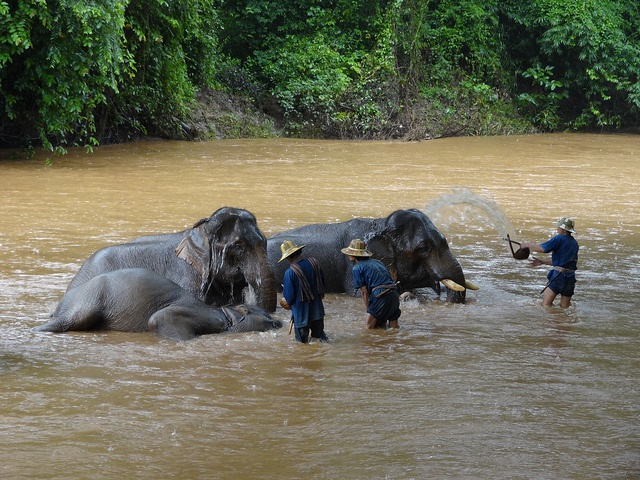Describe the objects in this image and their specific colors. I can see elephant in green, gray, darkgray, and black tones, elephant in green, black, gray, and darkgray tones, elephant in green, black, gray, and darkgray tones, people in green, black, navy, gray, and darkblue tones, and people in green, black, gray, navy, and darkgray tones in this image. 